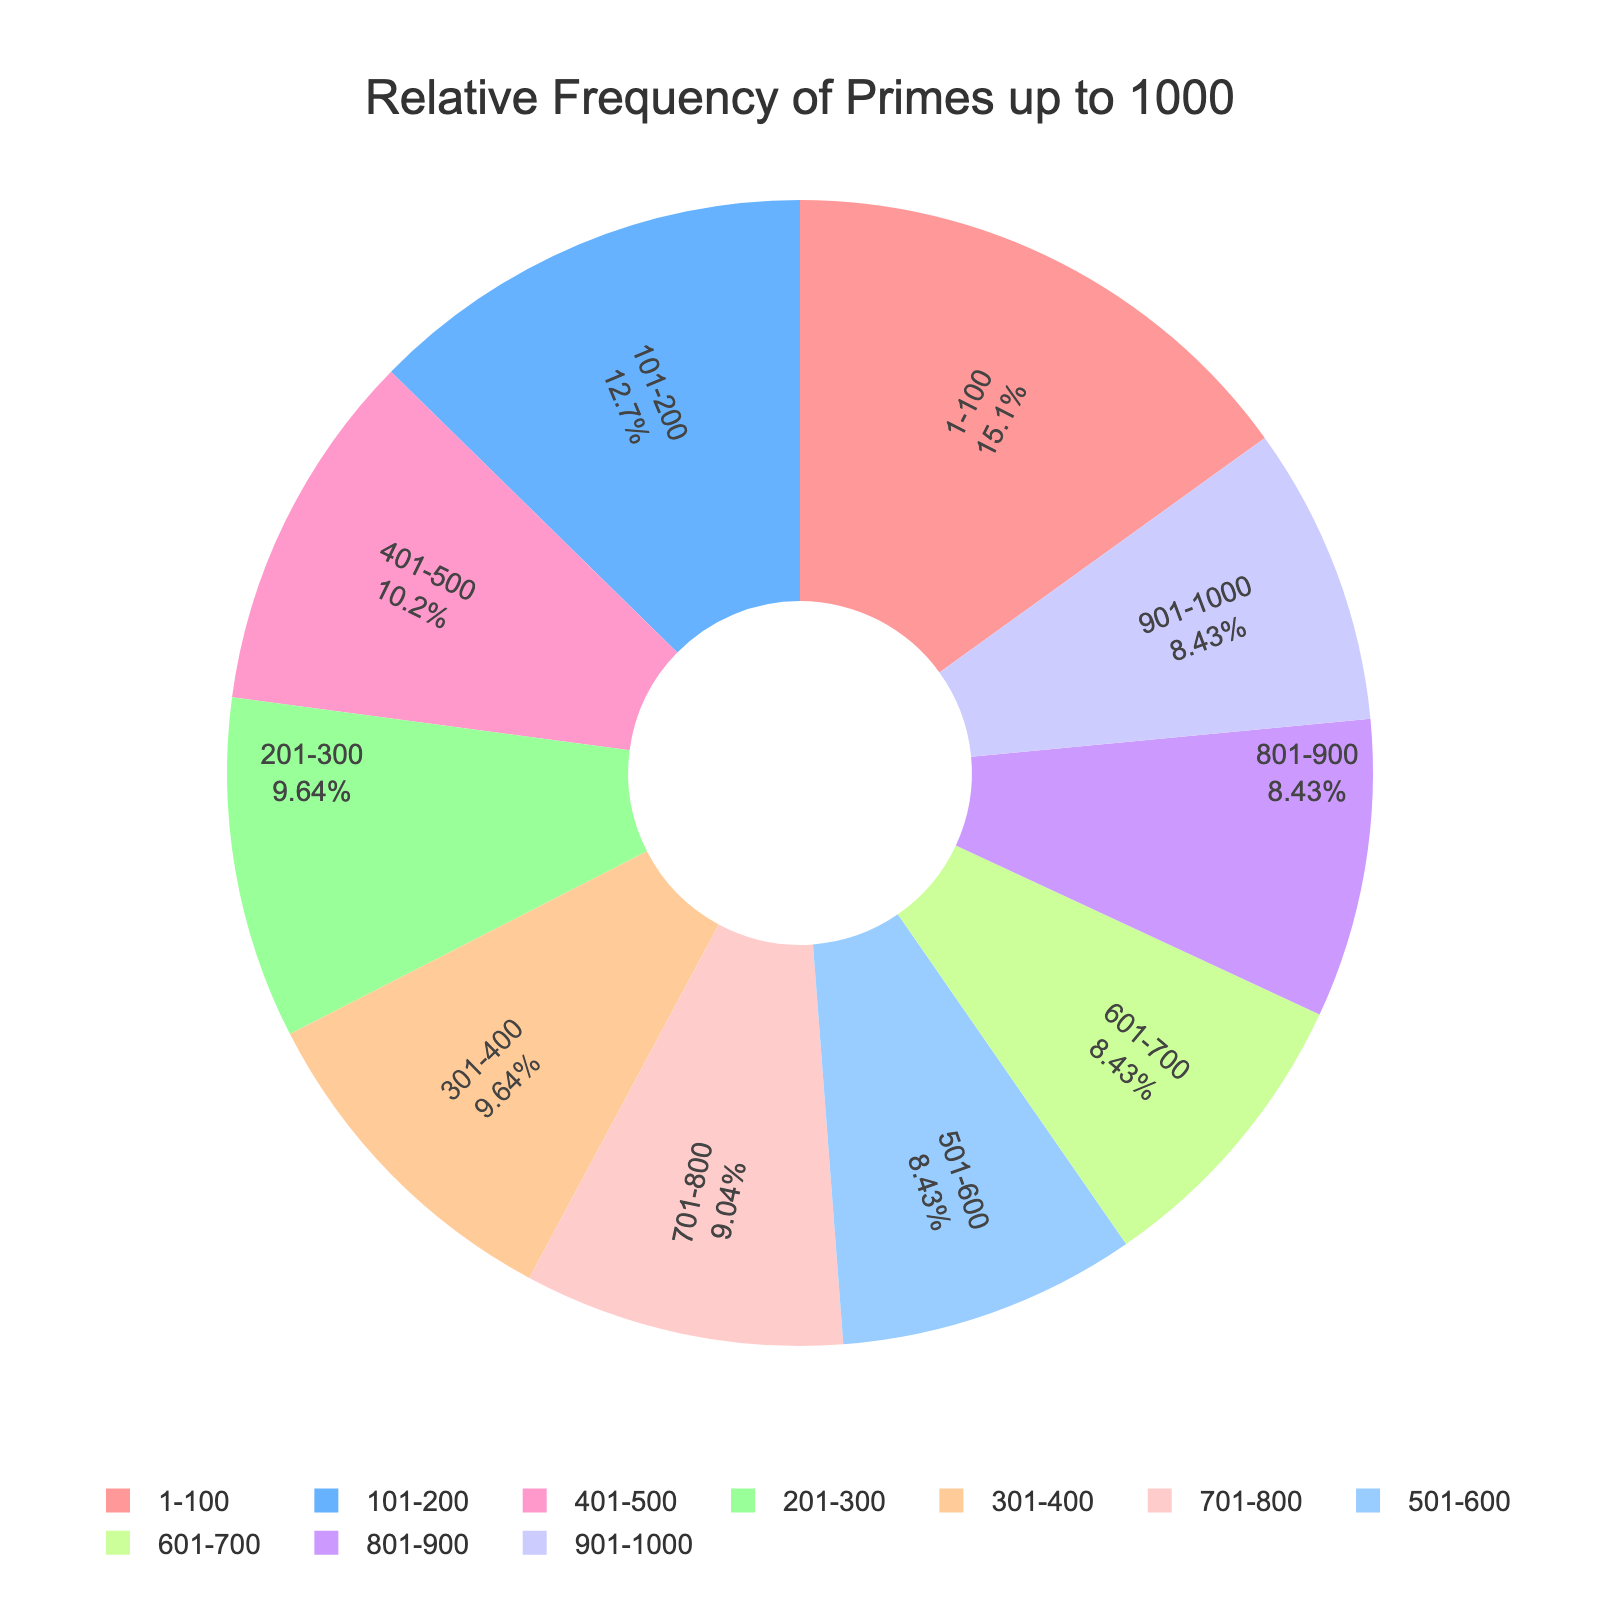What's the relative frequency of primes in the range 301-400? The relative frequency of primes in each range is labeled directly on the pie chart. For the range 301-400, the label shows a value of 16%.
Answer: 16% Which range has the highest relative frequency of primes? To find this, scan the pie chart for the largest segment. The range 1-100 has the largest portion, labeled as 25%, which is the highest frequency.
Answer: 1-100 What is the relative frequency difference between the ranges 1-100 and 101-200? The relative frequency for 1-100 is 25% and for 101-200 is 21%. Subtracting these values: 25% - 21% = 4%.
Answer: 4% How do the relative frequencies of primes in the ranges 601-700 and 901-1000 compare? Both 601-700 and 901-1000 segments have the same relative frequency of primes, labeled as 14% each.
Answer: They are equal What's the combined relative frequency of primes in the first 200 numbers (1-200)? Add the relative frequencies of the first two ranges: 25% (1-100) + 21% (101-200) = 46%.
Answer: 46% Which range has the smallest relative frequency of primes? The smallest segment on the pie chart represents the ranges 501-600, 601-700, 801-900, and 901-1000, all labeled as 14%. These are the ranges with the smallest relative frequency.
Answer: 501-600, 601-700, 801-900, 901-1000 What is the average relative frequency of primes across all ranges? Add all the relative frequencies and divide by the number of ranges: (25% + 21% + 16% + 16% + 17% + 14% + 14% + 15% + 14% + 14%) / 10 = 166% / 10 = 16.6%.
Answer: 16.6% What are the colors used for the range 1-100 and 201-300? The pie chart uses different colors for each range. For 1-100, the segment appears in a reddish color, and for 201-300, the segment appears in green.
Answer: Red for 1-100; green for 201-300 